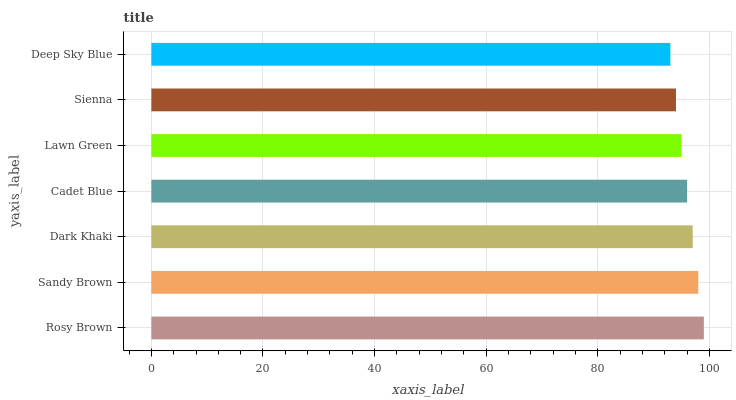Is Deep Sky Blue the minimum?
Answer yes or no. Yes. Is Rosy Brown the maximum?
Answer yes or no. Yes. Is Sandy Brown the minimum?
Answer yes or no. No. Is Sandy Brown the maximum?
Answer yes or no. No. Is Rosy Brown greater than Sandy Brown?
Answer yes or no. Yes. Is Sandy Brown less than Rosy Brown?
Answer yes or no. Yes. Is Sandy Brown greater than Rosy Brown?
Answer yes or no. No. Is Rosy Brown less than Sandy Brown?
Answer yes or no. No. Is Cadet Blue the high median?
Answer yes or no. Yes. Is Cadet Blue the low median?
Answer yes or no. Yes. Is Rosy Brown the high median?
Answer yes or no. No. Is Rosy Brown the low median?
Answer yes or no. No. 